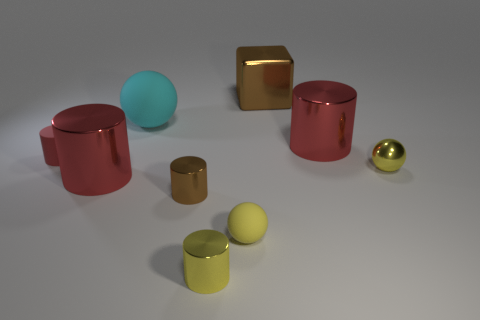Subtract all green spheres. How many red cylinders are left? 3 Subtract 1 cylinders. How many cylinders are left? 4 Subtract all yellow cylinders. How many cylinders are left? 4 Subtract all tiny brown metal cylinders. How many cylinders are left? 4 Subtract all blue cylinders. Subtract all brown blocks. How many cylinders are left? 5 Subtract all spheres. How many objects are left? 6 Add 8 large brown metal cubes. How many large brown metal cubes exist? 9 Subtract 1 red cylinders. How many objects are left? 8 Subtract all gray metal spheres. Subtract all red metallic cylinders. How many objects are left? 7 Add 4 large cyan balls. How many large cyan balls are left? 5 